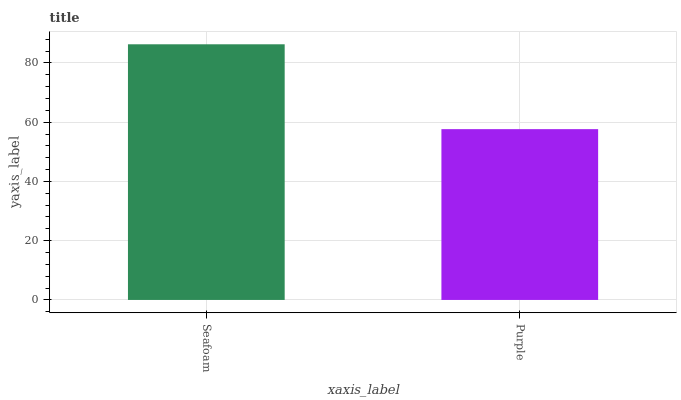Is Purple the minimum?
Answer yes or no. Yes. Is Seafoam the maximum?
Answer yes or no. Yes. Is Purple the maximum?
Answer yes or no. No. Is Seafoam greater than Purple?
Answer yes or no. Yes. Is Purple less than Seafoam?
Answer yes or no. Yes. Is Purple greater than Seafoam?
Answer yes or no. No. Is Seafoam less than Purple?
Answer yes or no. No. Is Seafoam the high median?
Answer yes or no. Yes. Is Purple the low median?
Answer yes or no. Yes. Is Purple the high median?
Answer yes or no. No. Is Seafoam the low median?
Answer yes or no. No. 